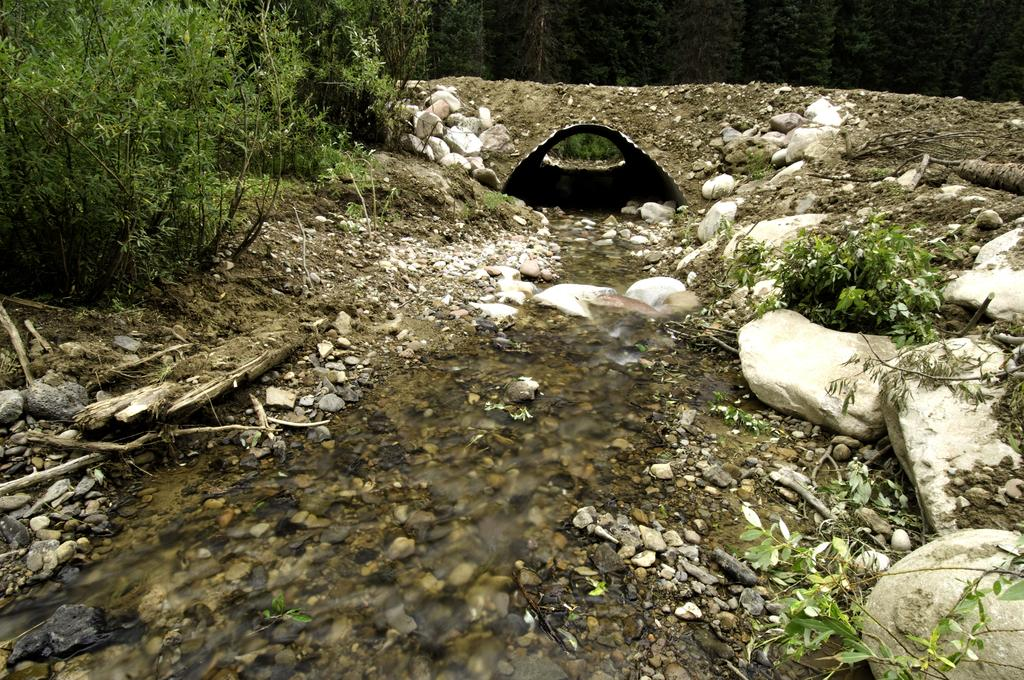What is the primary element visible in the image? There is water in the image. What other objects or features can be seen in the image? There are stones, plants, trees, and a small tunnel in the image. What type of cough does the uncle have in the image? There is no uncle or cough present in the image. What type of flesh can be seen on the plants in the image? There are no references to flesh in the image; it features water, stones, plants, trees, and a small tunnel. 